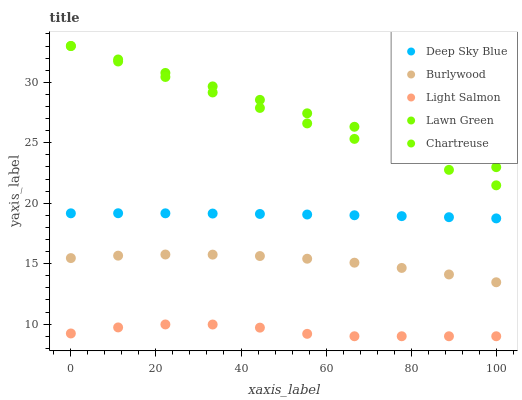Does Light Salmon have the minimum area under the curve?
Answer yes or no. Yes. Does Lawn Green have the maximum area under the curve?
Answer yes or no. Yes. Does Lawn Green have the minimum area under the curve?
Answer yes or no. No. Does Light Salmon have the maximum area under the curve?
Answer yes or no. No. Is Chartreuse the smoothest?
Answer yes or no. Yes. Is Light Salmon the roughest?
Answer yes or no. Yes. Is Lawn Green the smoothest?
Answer yes or no. No. Is Lawn Green the roughest?
Answer yes or no. No. Does Light Salmon have the lowest value?
Answer yes or no. Yes. Does Lawn Green have the lowest value?
Answer yes or no. No. Does Chartreuse have the highest value?
Answer yes or no. Yes. Does Light Salmon have the highest value?
Answer yes or no. No. Is Deep Sky Blue less than Lawn Green?
Answer yes or no. Yes. Is Burlywood greater than Light Salmon?
Answer yes or no. Yes. Does Chartreuse intersect Lawn Green?
Answer yes or no. Yes. Is Chartreuse less than Lawn Green?
Answer yes or no. No. Is Chartreuse greater than Lawn Green?
Answer yes or no. No. Does Deep Sky Blue intersect Lawn Green?
Answer yes or no. No. 